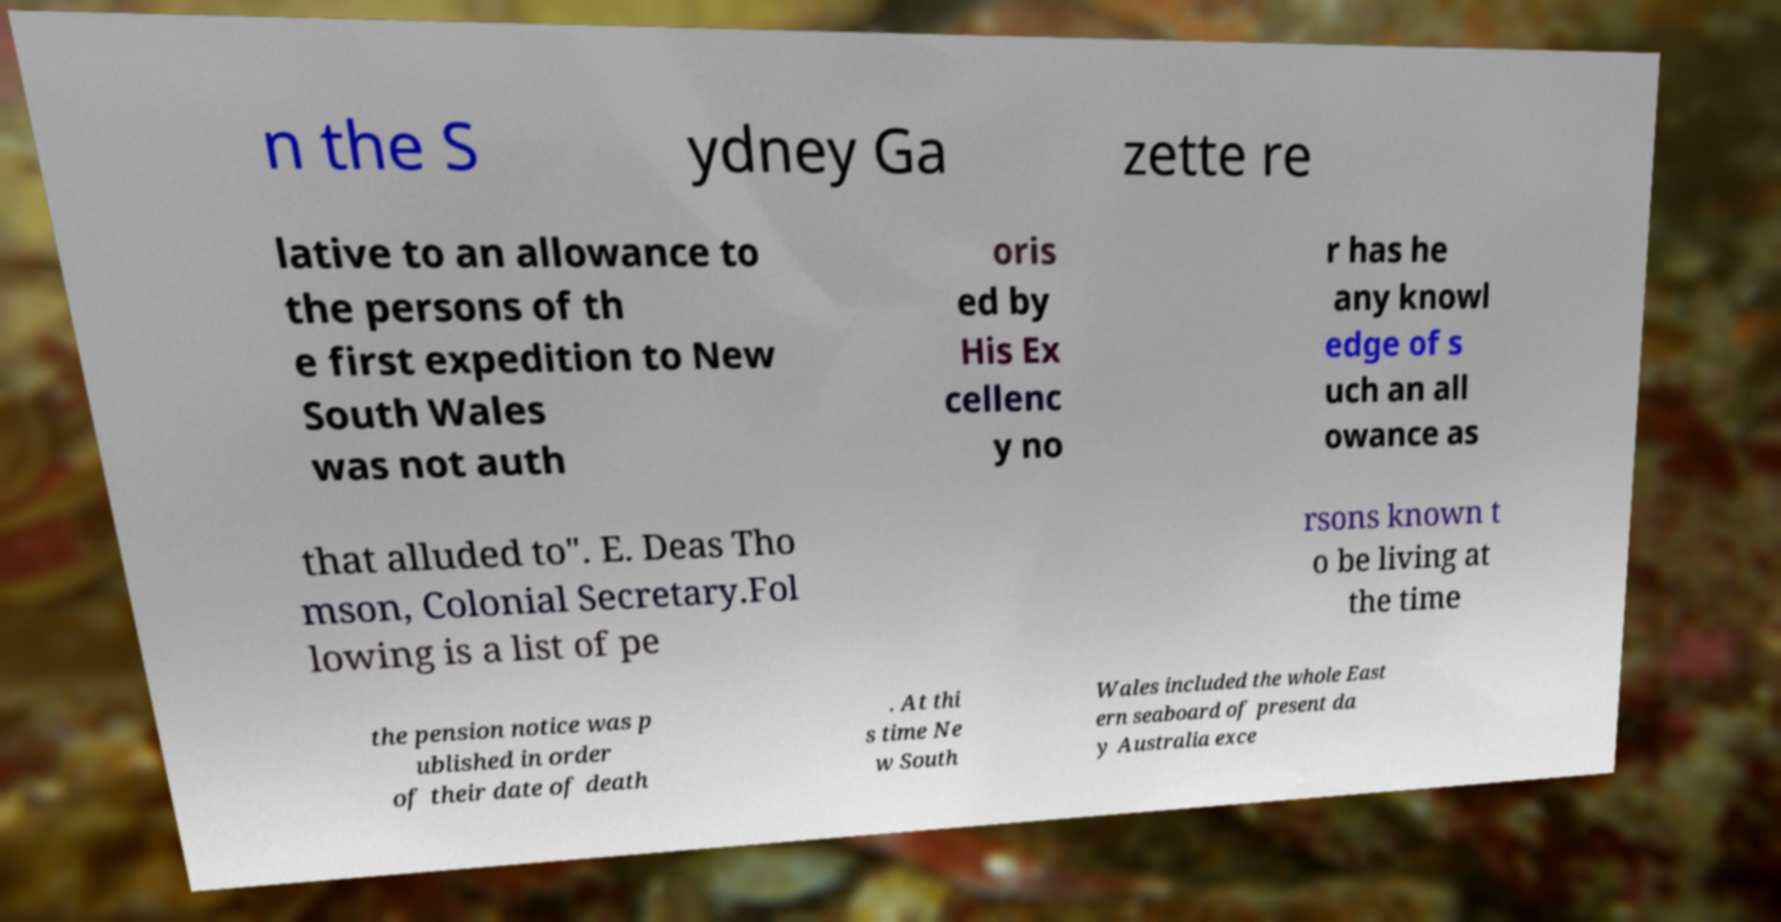I need the written content from this picture converted into text. Can you do that? n the S ydney Ga zette re lative to an allowance to the persons of th e first expedition to New South Wales was not auth oris ed by His Ex cellenc y no r has he any knowl edge of s uch an all owance as that alluded to". E. Deas Tho mson, Colonial Secretary.Fol lowing is a list of pe rsons known t o be living at the time the pension notice was p ublished in order of their date of death . At thi s time Ne w South Wales included the whole East ern seaboard of present da y Australia exce 